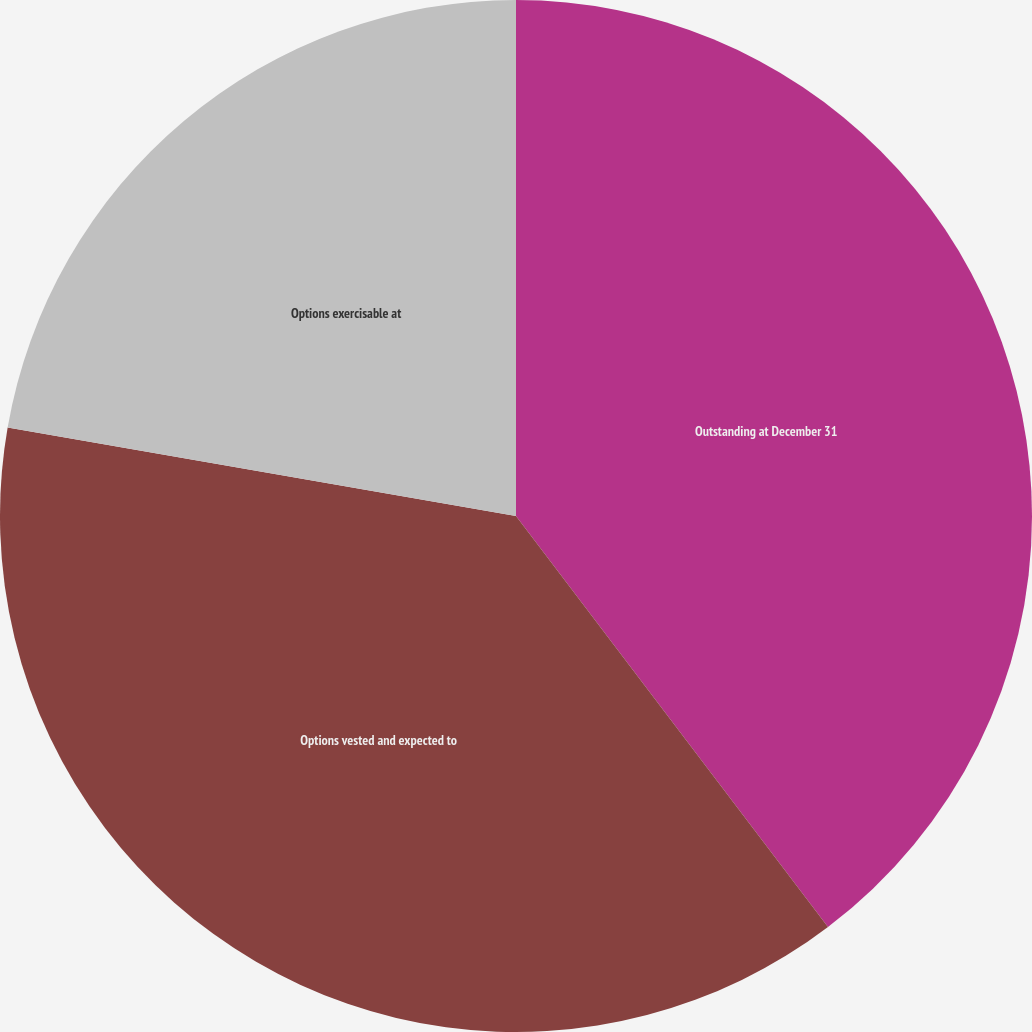Convert chart. <chart><loc_0><loc_0><loc_500><loc_500><pie_chart><fcel>Outstanding at December 31<fcel>Options vested and expected to<fcel>Options exercisable at<nl><fcel>39.67%<fcel>38.08%<fcel>22.26%<nl></chart> 